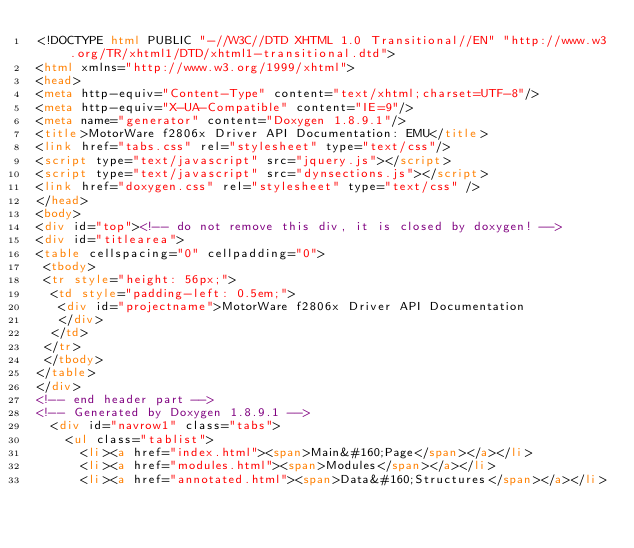Convert code to text. <code><loc_0><loc_0><loc_500><loc_500><_HTML_><!DOCTYPE html PUBLIC "-//W3C//DTD XHTML 1.0 Transitional//EN" "http://www.w3.org/TR/xhtml1/DTD/xhtml1-transitional.dtd">
<html xmlns="http://www.w3.org/1999/xhtml">
<head>
<meta http-equiv="Content-Type" content="text/xhtml;charset=UTF-8"/>
<meta http-equiv="X-UA-Compatible" content="IE=9"/>
<meta name="generator" content="Doxygen 1.8.9.1"/>
<title>MotorWare f2806x Driver API Documentation: EMU</title>
<link href="tabs.css" rel="stylesheet" type="text/css"/>
<script type="text/javascript" src="jquery.js"></script>
<script type="text/javascript" src="dynsections.js"></script>
<link href="doxygen.css" rel="stylesheet" type="text/css" />
</head>
<body>
<div id="top"><!-- do not remove this div, it is closed by doxygen! -->
<div id="titlearea">
<table cellspacing="0" cellpadding="0">
 <tbody>
 <tr style="height: 56px;">
  <td style="padding-left: 0.5em;">
   <div id="projectname">MotorWare f2806x Driver API Documentation
   </div>
  </td>
 </tr>
 </tbody>
</table>
</div>
<!-- end header part -->
<!-- Generated by Doxygen 1.8.9.1 -->
  <div id="navrow1" class="tabs">
    <ul class="tablist">
      <li><a href="index.html"><span>Main&#160;Page</span></a></li>
      <li><a href="modules.html"><span>Modules</span></a></li>
      <li><a href="annotated.html"><span>Data&#160;Structures</span></a></li></code> 